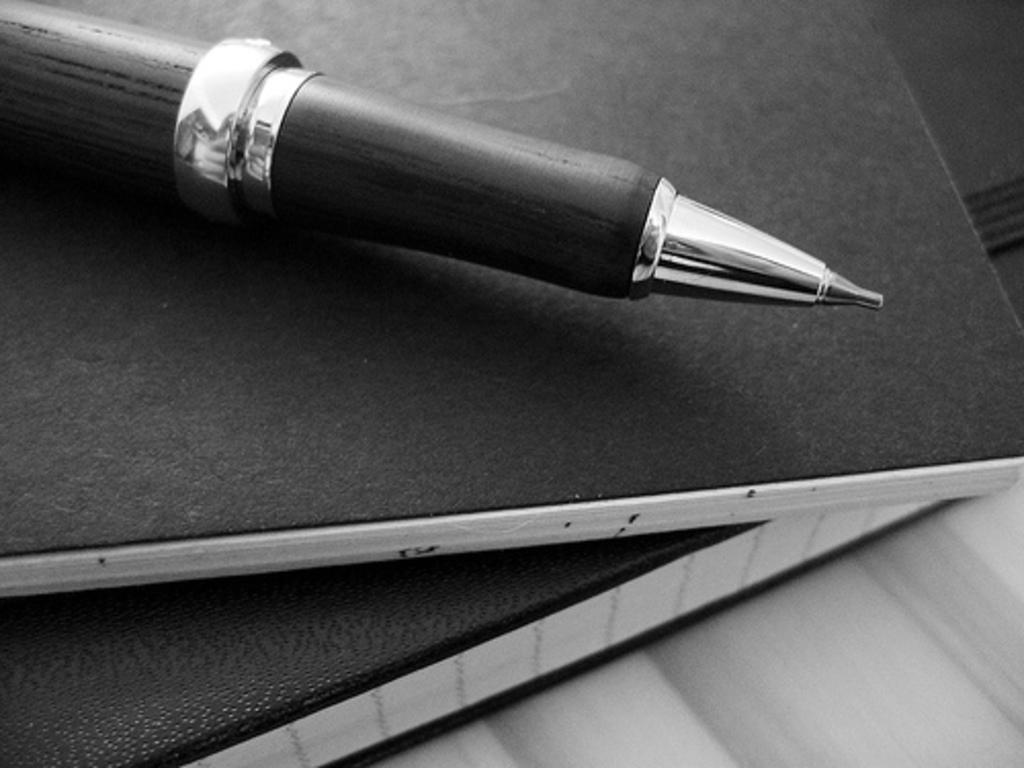What objects can be seen in the image? There are books in the image. Is there anything else on the books? Yes, a pen is on one of the books. How is the image presented? The image is in black and white. What type of wealth is depicted in the image? There is no depiction of wealth in the image; it features books and a pen. What story is being told in the image? The image does not tell a story; it simply shows books and a pen. 